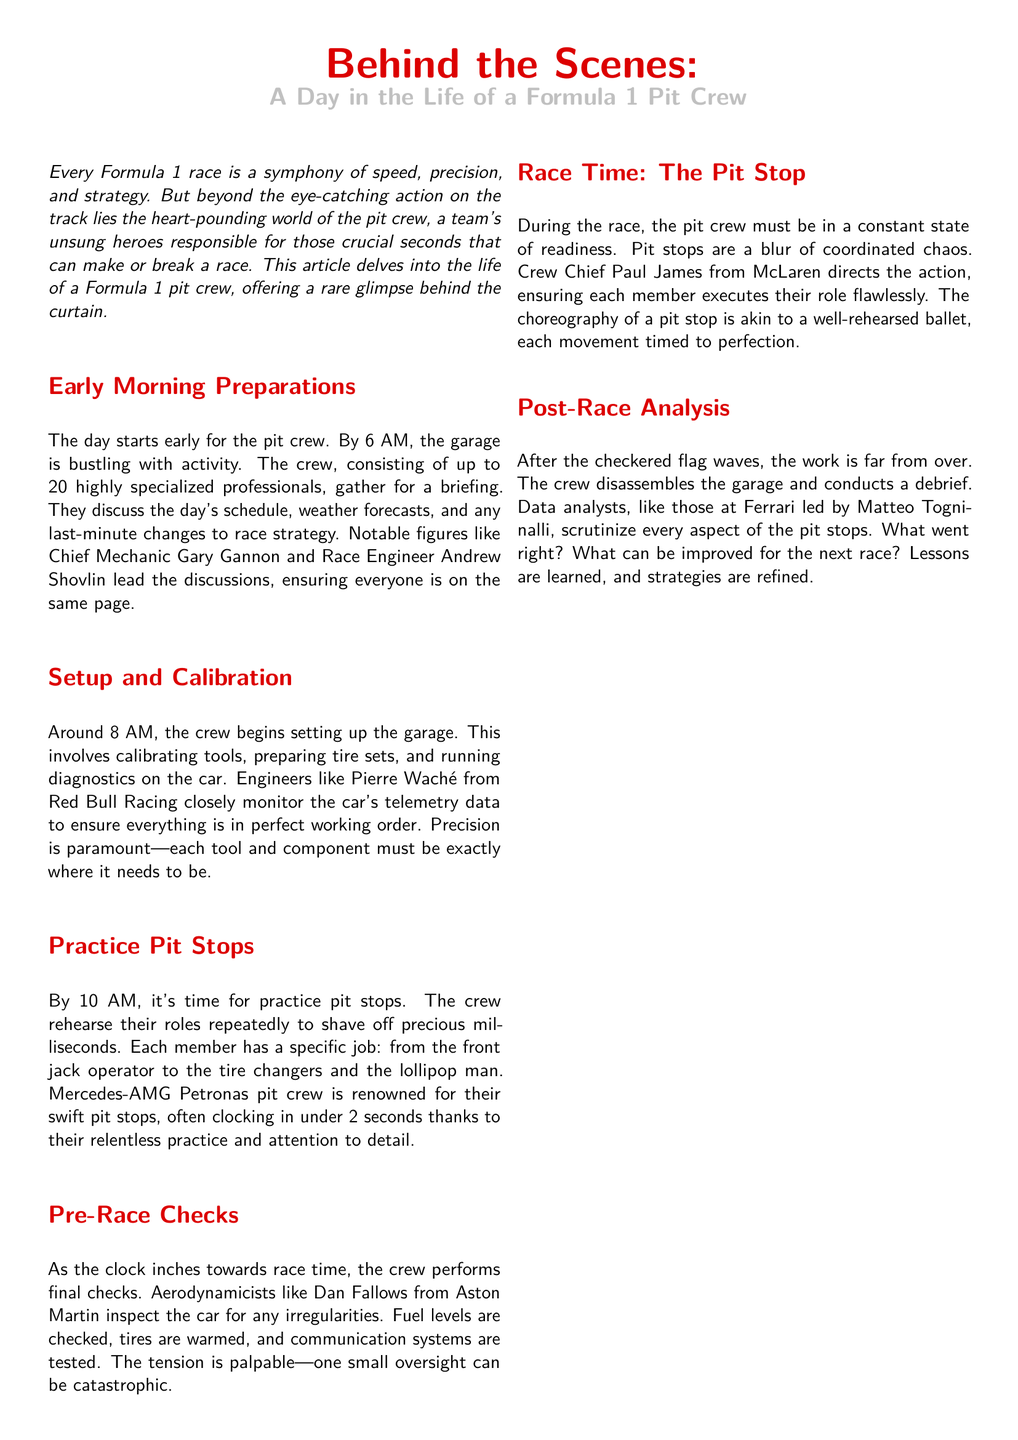What time does the day start for the pit crew? The document states that the pit crew's day starts early at 6 AM.
Answer: 6 AM Who leads the discussions during the morning briefing? The briefing discussion is led by notable figures such as Chief Mechanic Gary Gannon and Race Engineer Andrew Shovlin.
Answer: Gary Gannon and Andrew Shovlin What is the purpose of practice pit stops? The crew practices pit stops to rehearse their roles repeatedly and to shave off precious milliseconds.
Answer: To shave off precious milliseconds Which team is mentioned as being renowned for their swift pit stops? The document highlights the Mercedes-AMG Petronas pit crew as renowned for their swift pit stops.
Answer: Mercedes-AMG Petronas What is the role of the crew chief during the race? The crew chief directs the action and ensures each member executes their role flawlessly.
Answer: Directs the action Who leads the data analysis post-race? Data analysts at Ferrari led by Matteo Togninalli are responsible for post-race analysis.
Answer: Matteo Togninalli What is the overall conclusion about the pit crew's role? The conclusion emphasizes that the life of a Formula 1 pit crew represents teamwork and their role is pivotal to every race's success.
Answer: Teamwork makes the dream work How many specialized professionals are in the pit crew? The document states that the pit crew consists of up to 20 highly specialized professionals.
Answer: 20 What type of checks are performed as race time approaches? The crew performs final checks, including inspecting the car for irregularities and checking fuel levels.
Answer: Final checks 